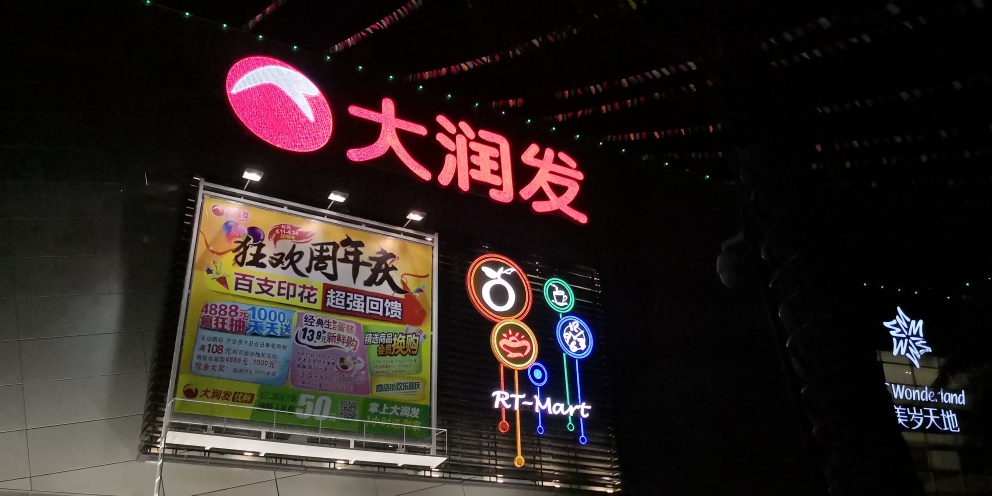Can you tell me about the marketing strategy reflected in the use of such vibrant neon colors at night? The use of vibrant neon colors against the dark night sky serves as an effective marketing strategy to capture the attention of passersby and motorists. It creates a visual contrast that makes the signage stand out, thereby increasing brand visibility and recall. It also conveys a sense of activity and liveliness which can be appealing, suggesting that the businesses are modern and exciting places to visit. 